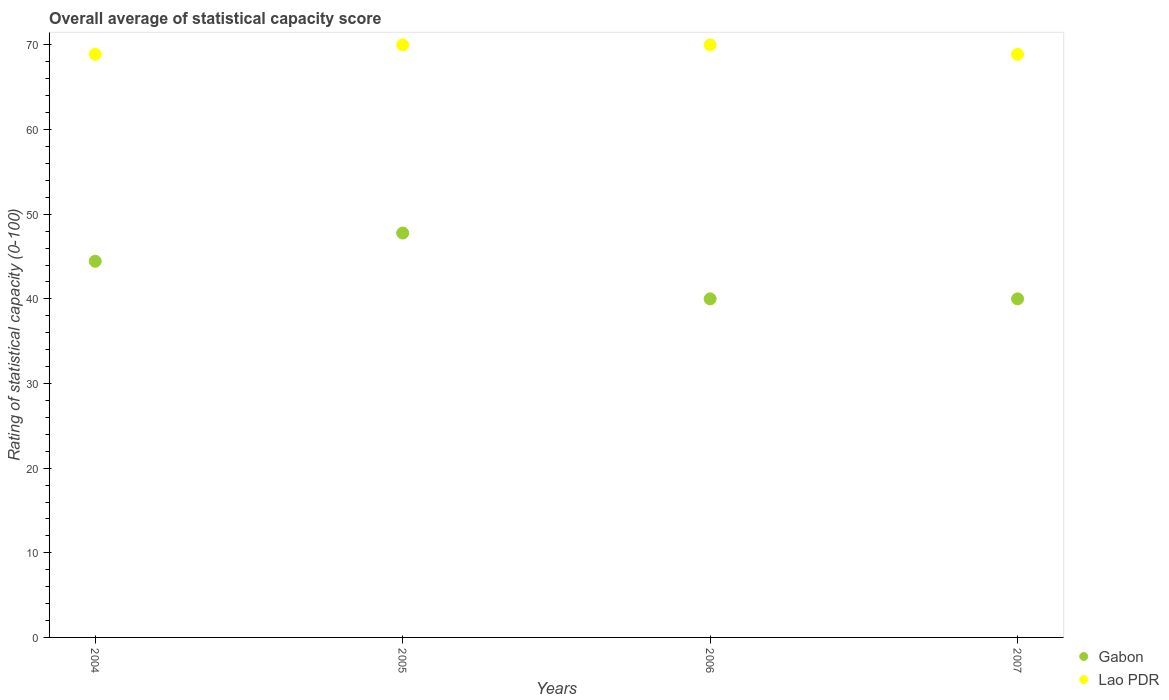How many different coloured dotlines are there?
Your answer should be compact. 2. What is the rating of statistical capacity in Gabon in 2005?
Give a very brief answer. 47.78. Across all years, what is the maximum rating of statistical capacity in Gabon?
Give a very brief answer. 47.78. Across all years, what is the minimum rating of statistical capacity in Lao PDR?
Provide a succinct answer. 68.89. In which year was the rating of statistical capacity in Gabon maximum?
Make the answer very short. 2005. What is the total rating of statistical capacity in Lao PDR in the graph?
Your answer should be compact. 277.78. What is the difference between the rating of statistical capacity in Gabon in 2005 and that in 2006?
Ensure brevity in your answer.  7.78. What is the difference between the rating of statistical capacity in Lao PDR in 2006 and the rating of statistical capacity in Gabon in 2004?
Offer a terse response. 25.56. What is the average rating of statistical capacity in Gabon per year?
Keep it short and to the point. 43.06. In the year 2004, what is the difference between the rating of statistical capacity in Gabon and rating of statistical capacity in Lao PDR?
Provide a succinct answer. -24.44. In how many years, is the rating of statistical capacity in Gabon greater than 48?
Ensure brevity in your answer.  0. What is the ratio of the rating of statistical capacity in Lao PDR in 2005 to that in 2007?
Give a very brief answer. 1.02. Is the difference between the rating of statistical capacity in Gabon in 2005 and 2006 greater than the difference between the rating of statistical capacity in Lao PDR in 2005 and 2006?
Your response must be concise. Yes. What is the difference between the highest and the second highest rating of statistical capacity in Gabon?
Your answer should be very brief. 3.33. What is the difference between the highest and the lowest rating of statistical capacity in Gabon?
Keep it short and to the point. 7.78. Is the sum of the rating of statistical capacity in Lao PDR in 2004 and 2005 greater than the maximum rating of statistical capacity in Gabon across all years?
Your answer should be compact. Yes. Is the rating of statistical capacity in Gabon strictly less than the rating of statistical capacity in Lao PDR over the years?
Offer a very short reply. Yes. How many dotlines are there?
Offer a terse response. 2. How many years are there in the graph?
Provide a short and direct response. 4. What is the difference between two consecutive major ticks on the Y-axis?
Offer a very short reply. 10. Does the graph contain any zero values?
Offer a very short reply. No. Does the graph contain grids?
Provide a succinct answer. No. What is the title of the graph?
Your answer should be very brief. Overall average of statistical capacity score. Does "Marshall Islands" appear as one of the legend labels in the graph?
Keep it short and to the point. No. What is the label or title of the X-axis?
Keep it short and to the point. Years. What is the label or title of the Y-axis?
Provide a succinct answer. Rating of statistical capacity (0-100). What is the Rating of statistical capacity (0-100) of Gabon in 2004?
Make the answer very short. 44.44. What is the Rating of statistical capacity (0-100) of Lao PDR in 2004?
Give a very brief answer. 68.89. What is the Rating of statistical capacity (0-100) of Gabon in 2005?
Make the answer very short. 47.78. What is the Rating of statistical capacity (0-100) in Lao PDR in 2006?
Your response must be concise. 70. What is the Rating of statistical capacity (0-100) in Lao PDR in 2007?
Provide a succinct answer. 68.89. Across all years, what is the maximum Rating of statistical capacity (0-100) of Gabon?
Provide a succinct answer. 47.78. Across all years, what is the minimum Rating of statistical capacity (0-100) of Gabon?
Offer a very short reply. 40. Across all years, what is the minimum Rating of statistical capacity (0-100) in Lao PDR?
Your response must be concise. 68.89. What is the total Rating of statistical capacity (0-100) in Gabon in the graph?
Your response must be concise. 172.22. What is the total Rating of statistical capacity (0-100) of Lao PDR in the graph?
Your answer should be very brief. 277.78. What is the difference between the Rating of statistical capacity (0-100) in Lao PDR in 2004 and that in 2005?
Your answer should be very brief. -1.11. What is the difference between the Rating of statistical capacity (0-100) of Gabon in 2004 and that in 2006?
Ensure brevity in your answer.  4.44. What is the difference between the Rating of statistical capacity (0-100) of Lao PDR in 2004 and that in 2006?
Give a very brief answer. -1.11. What is the difference between the Rating of statistical capacity (0-100) of Gabon in 2004 and that in 2007?
Give a very brief answer. 4.44. What is the difference between the Rating of statistical capacity (0-100) of Lao PDR in 2004 and that in 2007?
Offer a very short reply. 0. What is the difference between the Rating of statistical capacity (0-100) of Gabon in 2005 and that in 2006?
Your answer should be very brief. 7.78. What is the difference between the Rating of statistical capacity (0-100) of Gabon in 2005 and that in 2007?
Your answer should be compact. 7.78. What is the difference between the Rating of statistical capacity (0-100) of Gabon in 2006 and that in 2007?
Provide a short and direct response. 0. What is the difference between the Rating of statistical capacity (0-100) in Lao PDR in 2006 and that in 2007?
Provide a short and direct response. 1.11. What is the difference between the Rating of statistical capacity (0-100) of Gabon in 2004 and the Rating of statistical capacity (0-100) of Lao PDR in 2005?
Offer a terse response. -25.56. What is the difference between the Rating of statistical capacity (0-100) in Gabon in 2004 and the Rating of statistical capacity (0-100) in Lao PDR in 2006?
Keep it short and to the point. -25.56. What is the difference between the Rating of statistical capacity (0-100) in Gabon in 2004 and the Rating of statistical capacity (0-100) in Lao PDR in 2007?
Give a very brief answer. -24.44. What is the difference between the Rating of statistical capacity (0-100) of Gabon in 2005 and the Rating of statistical capacity (0-100) of Lao PDR in 2006?
Provide a short and direct response. -22.22. What is the difference between the Rating of statistical capacity (0-100) of Gabon in 2005 and the Rating of statistical capacity (0-100) of Lao PDR in 2007?
Keep it short and to the point. -21.11. What is the difference between the Rating of statistical capacity (0-100) of Gabon in 2006 and the Rating of statistical capacity (0-100) of Lao PDR in 2007?
Provide a succinct answer. -28.89. What is the average Rating of statistical capacity (0-100) in Gabon per year?
Ensure brevity in your answer.  43.06. What is the average Rating of statistical capacity (0-100) in Lao PDR per year?
Ensure brevity in your answer.  69.44. In the year 2004, what is the difference between the Rating of statistical capacity (0-100) of Gabon and Rating of statistical capacity (0-100) of Lao PDR?
Give a very brief answer. -24.44. In the year 2005, what is the difference between the Rating of statistical capacity (0-100) of Gabon and Rating of statistical capacity (0-100) of Lao PDR?
Provide a short and direct response. -22.22. In the year 2006, what is the difference between the Rating of statistical capacity (0-100) in Gabon and Rating of statistical capacity (0-100) in Lao PDR?
Your response must be concise. -30. In the year 2007, what is the difference between the Rating of statistical capacity (0-100) of Gabon and Rating of statistical capacity (0-100) of Lao PDR?
Provide a short and direct response. -28.89. What is the ratio of the Rating of statistical capacity (0-100) of Gabon in 2004 to that in 2005?
Provide a short and direct response. 0.93. What is the ratio of the Rating of statistical capacity (0-100) in Lao PDR in 2004 to that in 2005?
Your response must be concise. 0.98. What is the ratio of the Rating of statistical capacity (0-100) in Lao PDR in 2004 to that in 2006?
Offer a terse response. 0.98. What is the ratio of the Rating of statistical capacity (0-100) of Lao PDR in 2004 to that in 2007?
Provide a short and direct response. 1. What is the ratio of the Rating of statistical capacity (0-100) of Gabon in 2005 to that in 2006?
Keep it short and to the point. 1.19. What is the ratio of the Rating of statistical capacity (0-100) in Gabon in 2005 to that in 2007?
Provide a short and direct response. 1.19. What is the ratio of the Rating of statistical capacity (0-100) in Lao PDR in 2005 to that in 2007?
Offer a very short reply. 1.02. What is the ratio of the Rating of statistical capacity (0-100) in Gabon in 2006 to that in 2007?
Provide a succinct answer. 1. What is the ratio of the Rating of statistical capacity (0-100) in Lao PDR in 2006 to that in 2007?
Offer a terse response. 1.02. What is the difference between the highest and the second highest Rating of statistical capacity (0-100) of Lao PDR?
Keep it short and to the point. 0. What is the difference between the highest and the lowest Rating of statistical capacity (0-100) of Gabon?
Offer a terse response. 7.78. 